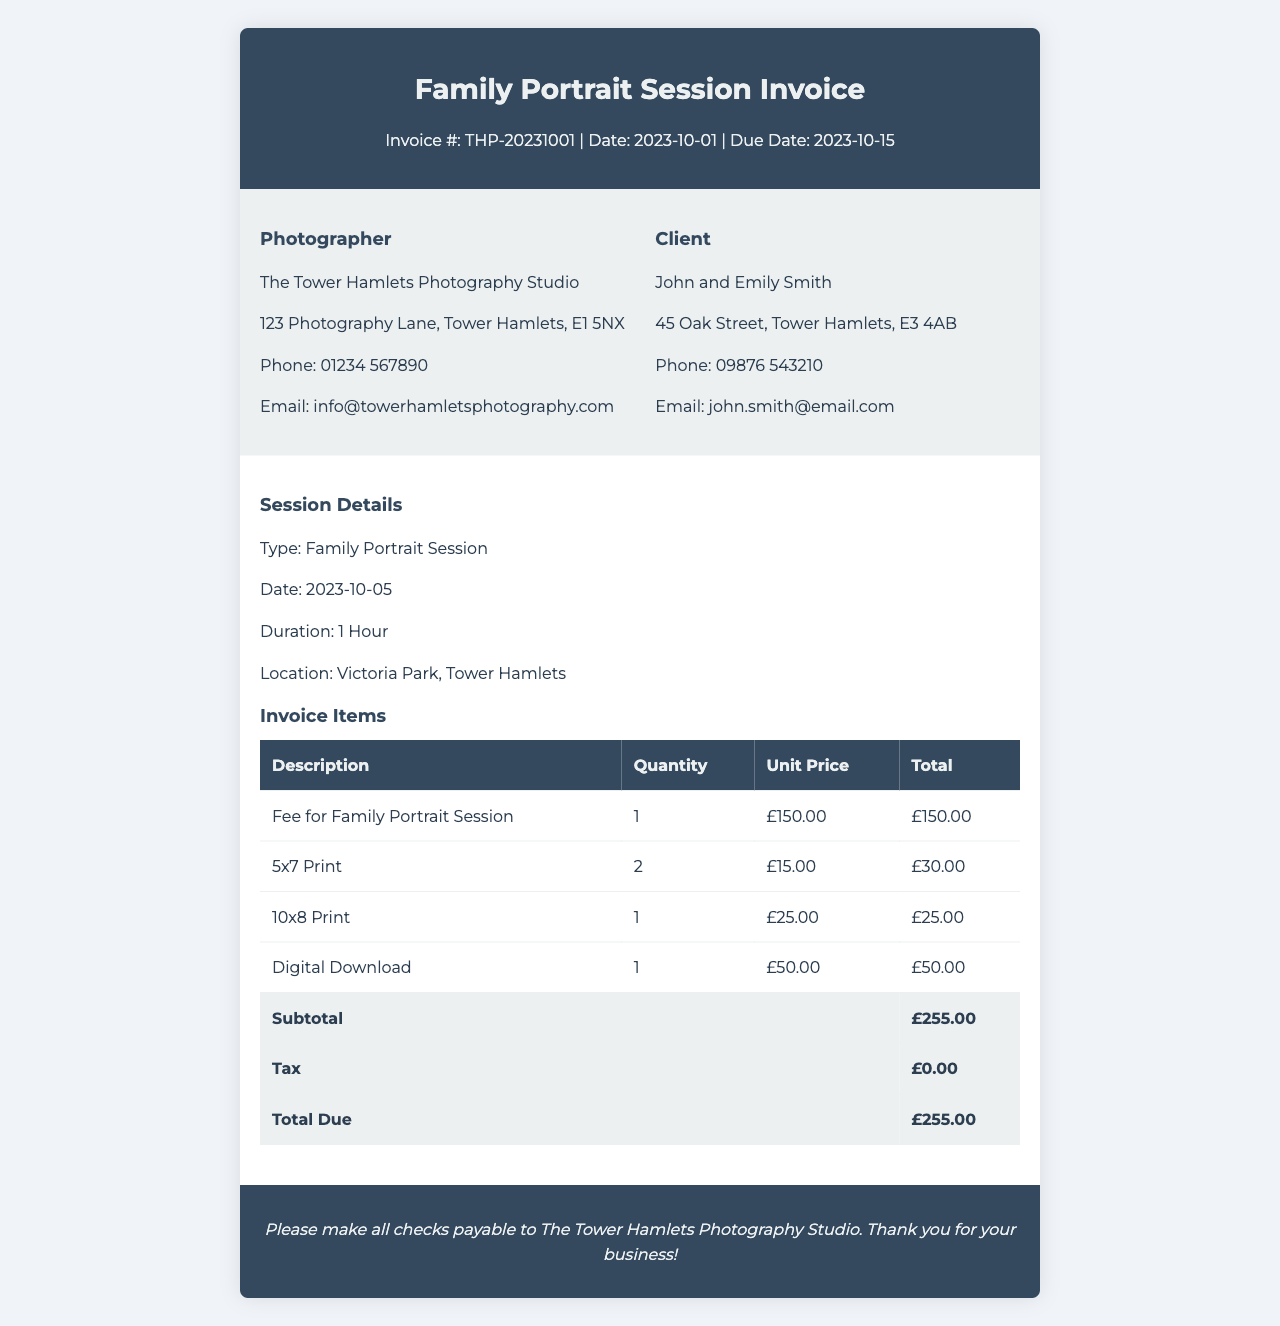What is the invoice number? The invoice number is specified in the document as part of the header section.
Answer: THP-20231001 Who is the photographer? The photographer's name is provided in the invoice's photographer information section.
Answer: The Tower Hamlets Photography Studio What is the session fee? The session fee is detailed in the invoice items section under the fee for the family portrait session.
Answer: £150.00 What is the due date for the invoice? The due date is stated in the invoice header.
Answer: 2023-10-15 How many 5x7 prints were ordered? The quantity of 5x7 prints is indicated in the invoice items table.
Answer: 2 What is the total due amount? The total amount due is summarized at the end of the invoice items table.
Answer: £255.00 Which location was chosen for the portrait session? The location is mentioned in the session details section of the document.
Answer: Victoria Park, Tower Hamlets What is the quantity of digital downloads included? The quantity of digital downloads is listed in the invoice items section.
Answer: 1 